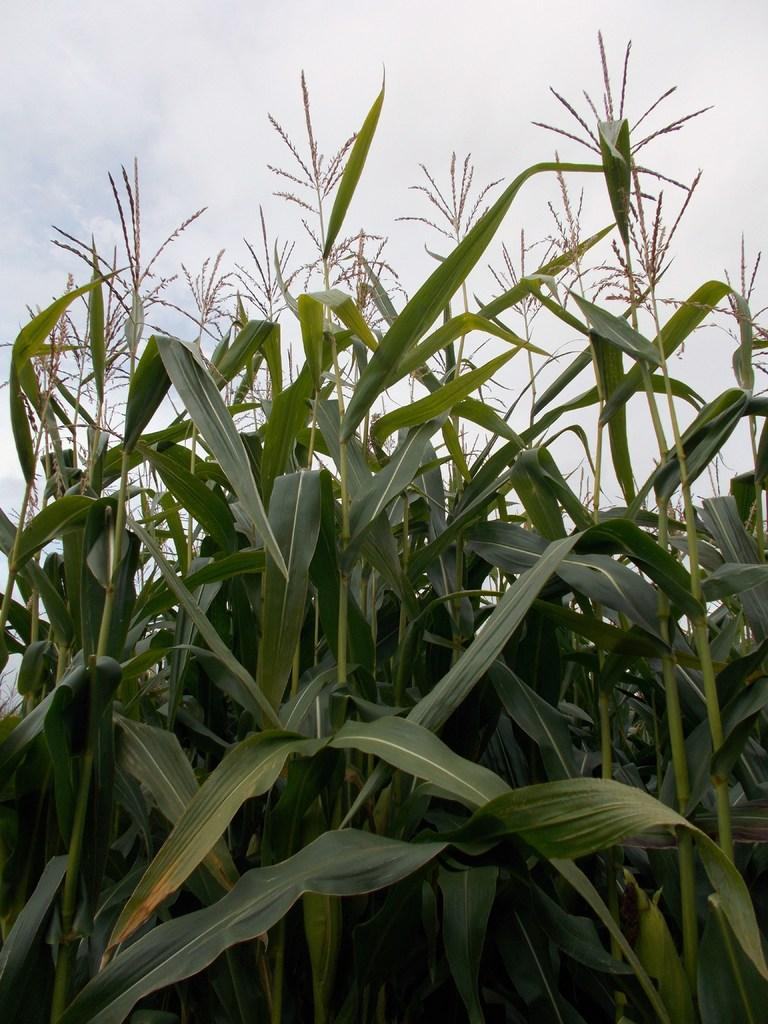What type of living organisms can be seen in the image? Plants can be seen in the image. What part of the natural environment is visible in the image? The sky is visible in the background of the image. What type of cave can be seen in the image? There is no cave present in the image; it features plants and the sky. How does the fly interact with the plants in the image? There is no fly present in the image, so it cannot be determined how it would interact with the plants. 